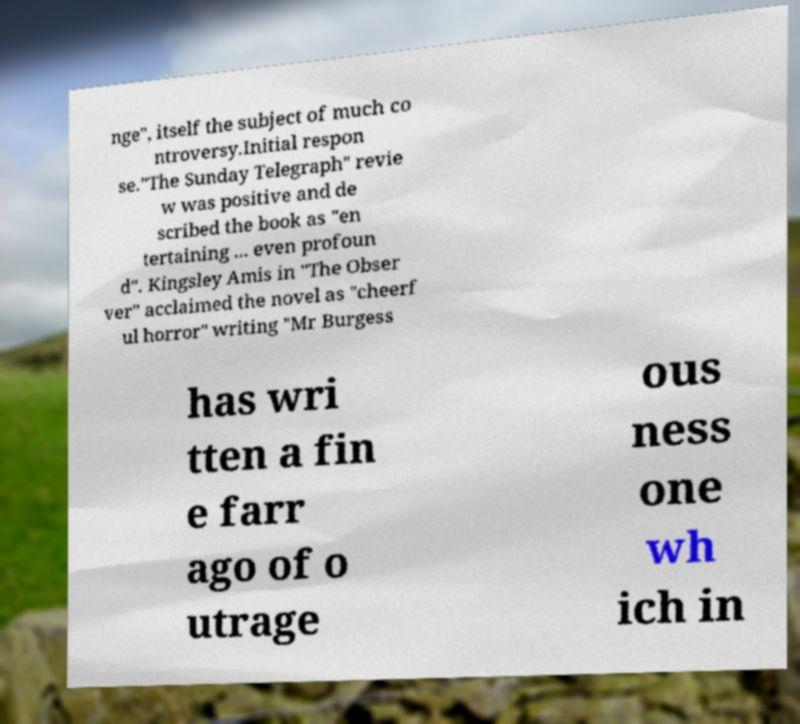There's text embedded in this image that I need extracted. Can you transcribe it verbatim? nge", itself the subject of much co ntroversy.Initial respon se."The Sunday Telegraph" revie w was positive and de scribed the book as "en tertaining ... even profoun d". Kingsley Amis in "The Obser ver" acclaimed the novel as "cheerf ul horror" writing "Mr Burgess has wri tten a fin e farr ago of o utrage ous ness one wh ich in 